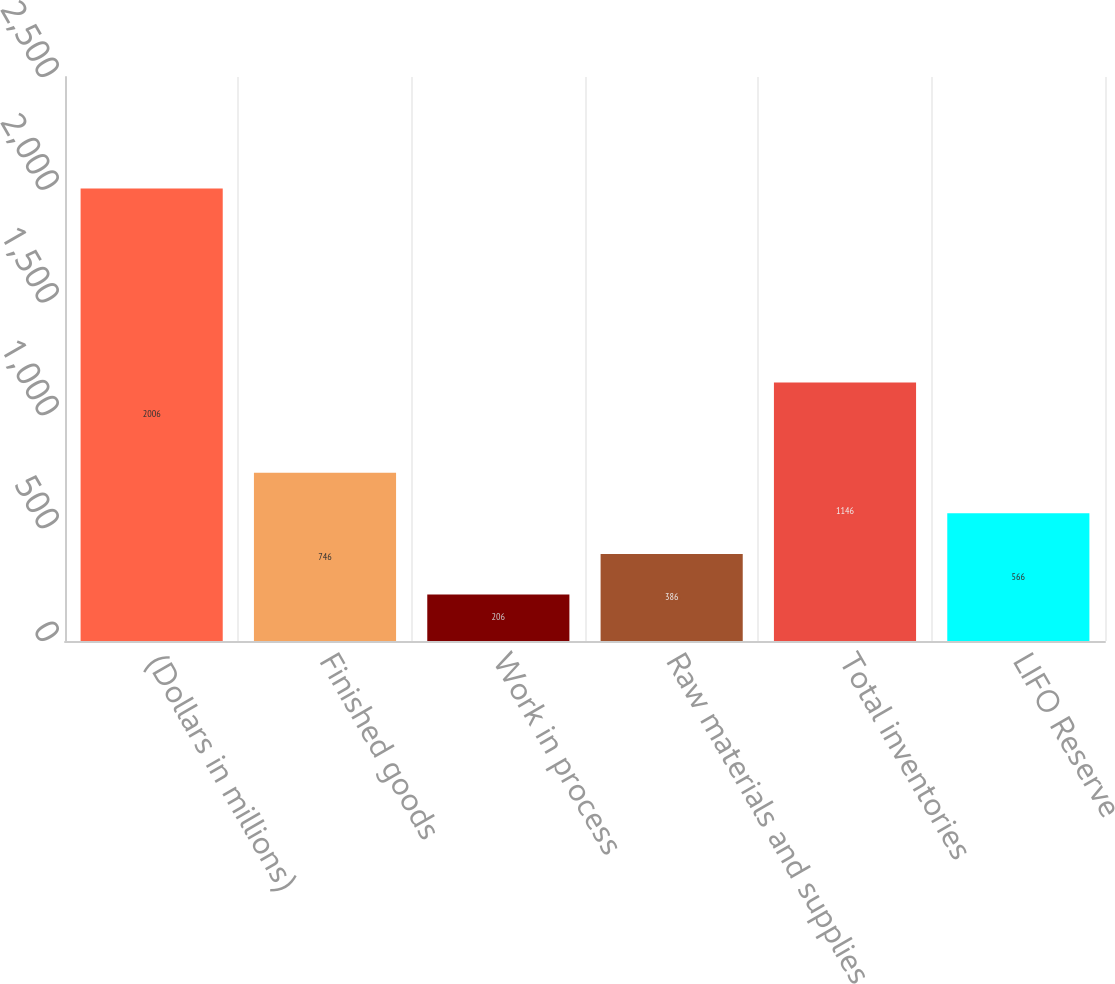<chart> <loc_0><loc_0><loc_500><loc_500><bar_chart><fcel>(Dollars in millions)<fcel>Finished goods<fcel>Work in process<fcel>Raw materials and supplies<fcel>Total inventories<fcel>LIFO Reserve<nl><fcel>2006<fcel>746<fcel>206<fcel>386<fcel>1146<fcel>566<nl></chart> 